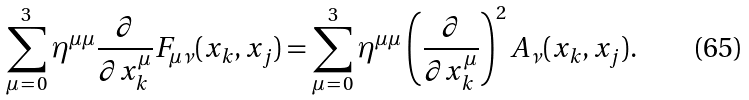<formula> <loc_0><loc_0><loc_500><loc_500>\sum _ { \mu \, = \, 0 } ^ { 3 } \eta ^ { \mu \mu } \frac { \partial } { \partial x _ { k } ^ { \mu } } F _ { \mu \nu } ( x _ { k } , x _ { j } ) = \sum _ { \mu \, = \, 0 } ^ { 3 } \eta ^ { \mu \mu } \left ( \frac { \partial } { \partial x _ { k } ^ { \mu } } \right ) ^ { 2 } A _ { \nu } ( x _ { k } , x _ { j } ) .</formula> 